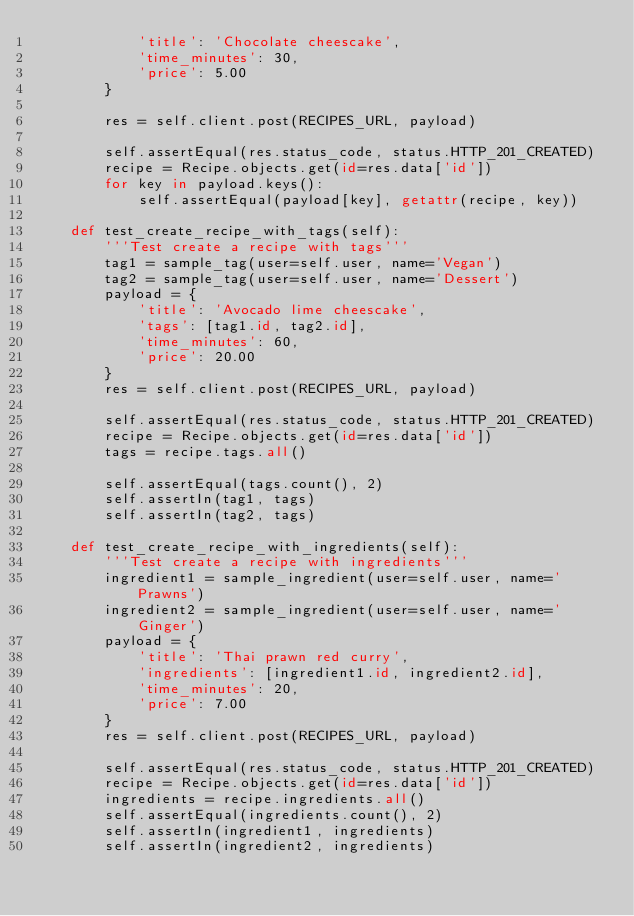<code> <loc_0><loc_0><loc_500><loc_500><_Python_>            'title': 'Chocolate cheescake',
            'time_minutes': 30,
            'price': 5.00
        }

        res = self.client.post(RECIPES_URL, payload)

        self.assertEqual(res.status_code, status.HTTP_201_CREATED)
        recipe = Recipe.objects.get(id=res.data['id'])
        for key in payload.keys():
            self.assertEqual(payload[key], getattr(recipe, key))

    def test_create_recipe_with_tags(self):
        '''Test create a recipe with tags'''
        tag1 = sample_tag(user=self.user, name='Vegan')
        tag2 = sample_tag(user=self.user, name='Dessert')
        payload = {
            'title': 'Avocado lime cheescake',
            'tags': [tag1.id, tag2.id],
            'time_minutes': 60,
            'price': 20.00
        }
        res = self.client.post(RECIPES_URL, payload)

        self.assertEqual(res.status_code, status.HTTP_201_CREATED)
        recipe = Recipe.objects.get(id=res.data['id'])
        tags = recipe.tags.all()

        self.assertEqual(tags.count(), 2)
        self.assertIn(tag1, tags)
        self.assertIn(tag2, tags)

    def test_create_recipe_with_ingredients(self):
        '''Test create a recipe with ingredients'''
        ingredient1 = sample_ingredient(user=self.user, name='Prawns')
        ingredient2 = sample_ingredient(user=self.user, name='Ginger')
        payload = {
            'title': 'Thai prawn red curry',
            'ingredients': [ingredient1.id, ingredient2.id],
            'time_minutes': 20,
            'price': 7.00
        }
        res = self.client.post(RECIPES_URL, payload)

        self.assertEqual(res.status_code, status.HTTP_201_CREATED)
        recipe = Recipe.objects.get(id=res.data['id'])
        ingredients = recipe.ingredients.all()
        self.assertEqual(ingredients.count(), 2)
        self.assertIn(ingredient1, ingredients)
        self.assertIn(ingredient2, ingredients)
</code> 